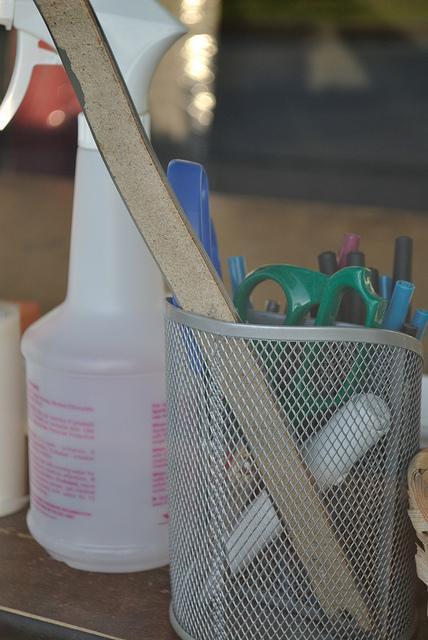How many scissors are visible?
Give a very brief answer. 2. How many of the people shown are children?
Give a very brief answer. 0. 